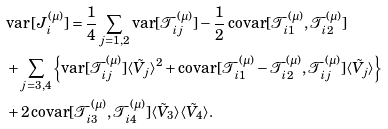<formula> <loc_0><loc_0><loc_500><loc_500>& \text {var} \, [ J _ { i } ^ { ( \mu ) } ] = \frac { 1 } { 4 } \sum _ { j = 1 , 2 } \text {var} [ \mathcal { T } _ { i j } ^ { ( \mu ) } ] - \frac { 1 } { 2 } \, \text {covar} [ \mathcal { T } _ { i 1 } ^ { ( \mu ) } , \mathcal { T } _ { i 2 } ^ { ( \mu ) } ] \\ & + \sum _ { j = 3 , 4 } \left \{ \text {var} [ \mathcal { T } _ { i j } ^ { ( \mu ) } ] \langle \tilde { V } _ { j } \rangle ^ { 2 } + \text {covar} [ \mathcal { T } _ { i 1 } ^ { ( \mu ) } - \mathcal { T } _ { i 2 } ^ { ( \mu ) } , \mathcal { T } _ { i j } ^ { ( \mu ) } ] \langle \tilde { V } _ { j } \rangle \right \} \\ & + 2 \, \text {covar} [ \mathcal { T } _ { i 3 } ^ { ( \mu ) } , \mathcal { T } _ { i 4 } ^ { ( \mu ) } ] \langle \tilde { V } _ { 3 } \rangle \langle \tilde { V } _ { 4 } \rangle .</formula> 